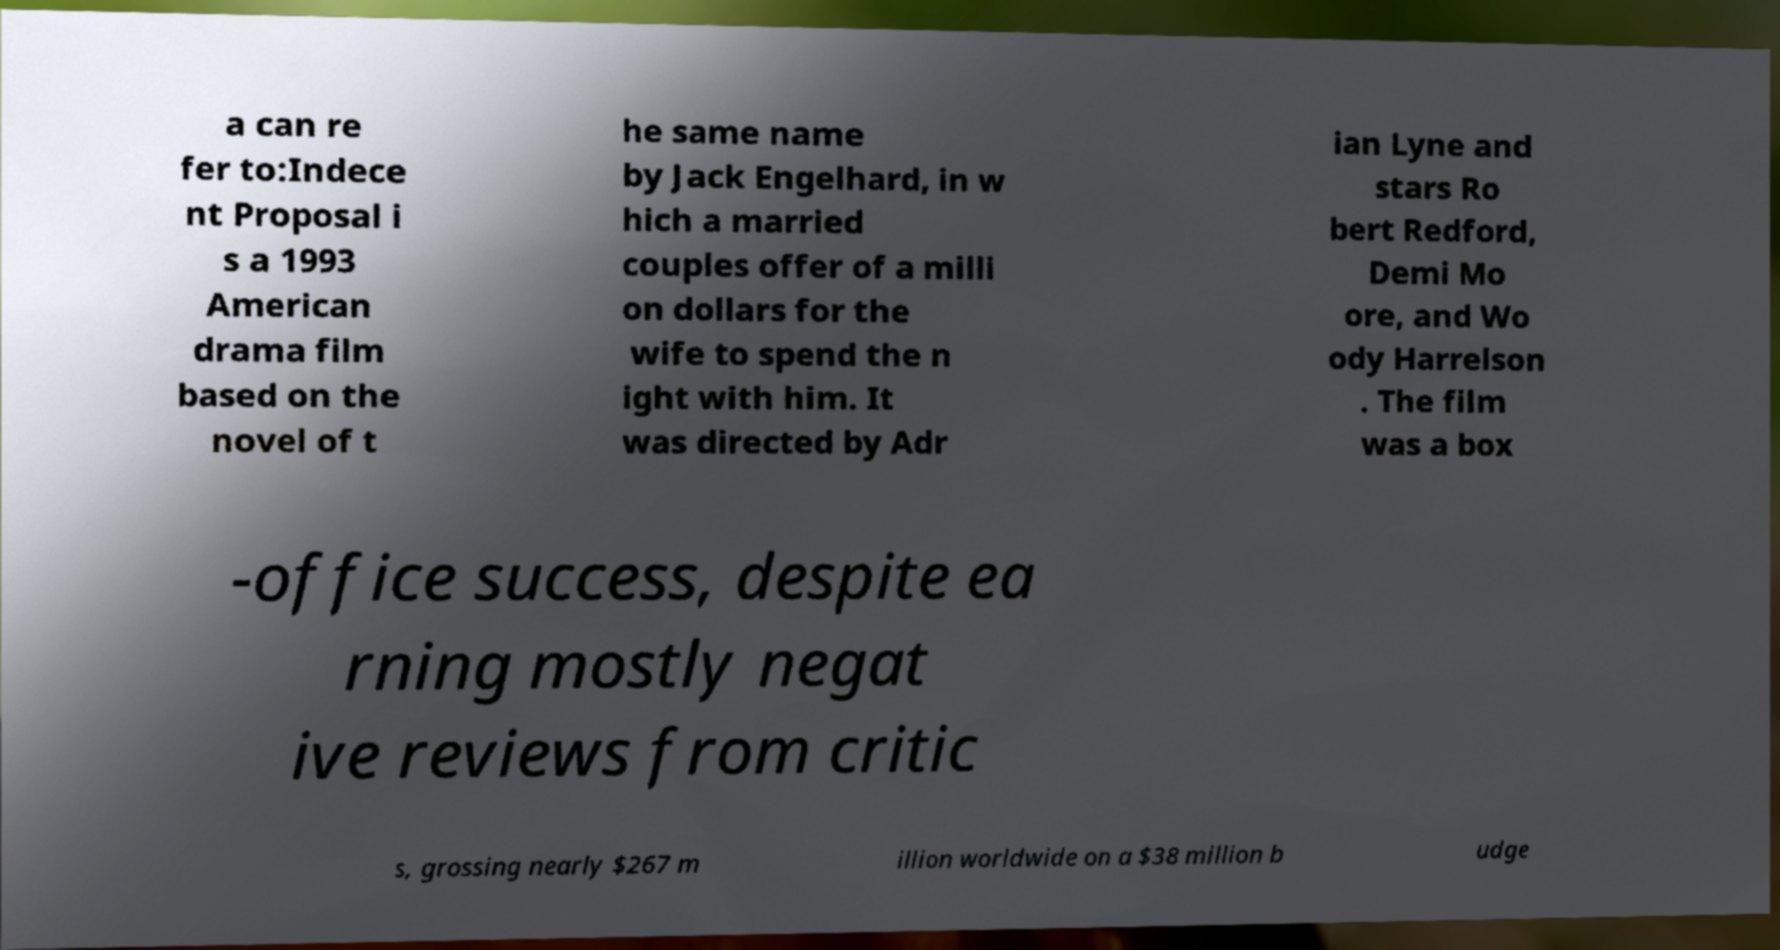What messages or text are displayed in this image? I need them in a readable, typed format. a can re fer to:Indece nt Proposal i s a 1993 American drama film based on the novel of t he same name by Jack Engelhard, in w hich a married couples offer of a milli on dollars for the wife to spend the n ight with him. It was directed by Adr ian Lyne and stars Ro bert Redford, Demi Mo ore, and Wo ody Harrelson . The film was a box -office success, despite ea rning mostly negat ive reviews from critic s, grossing nearly $267 m illion worldwide on a $38 million b udge 